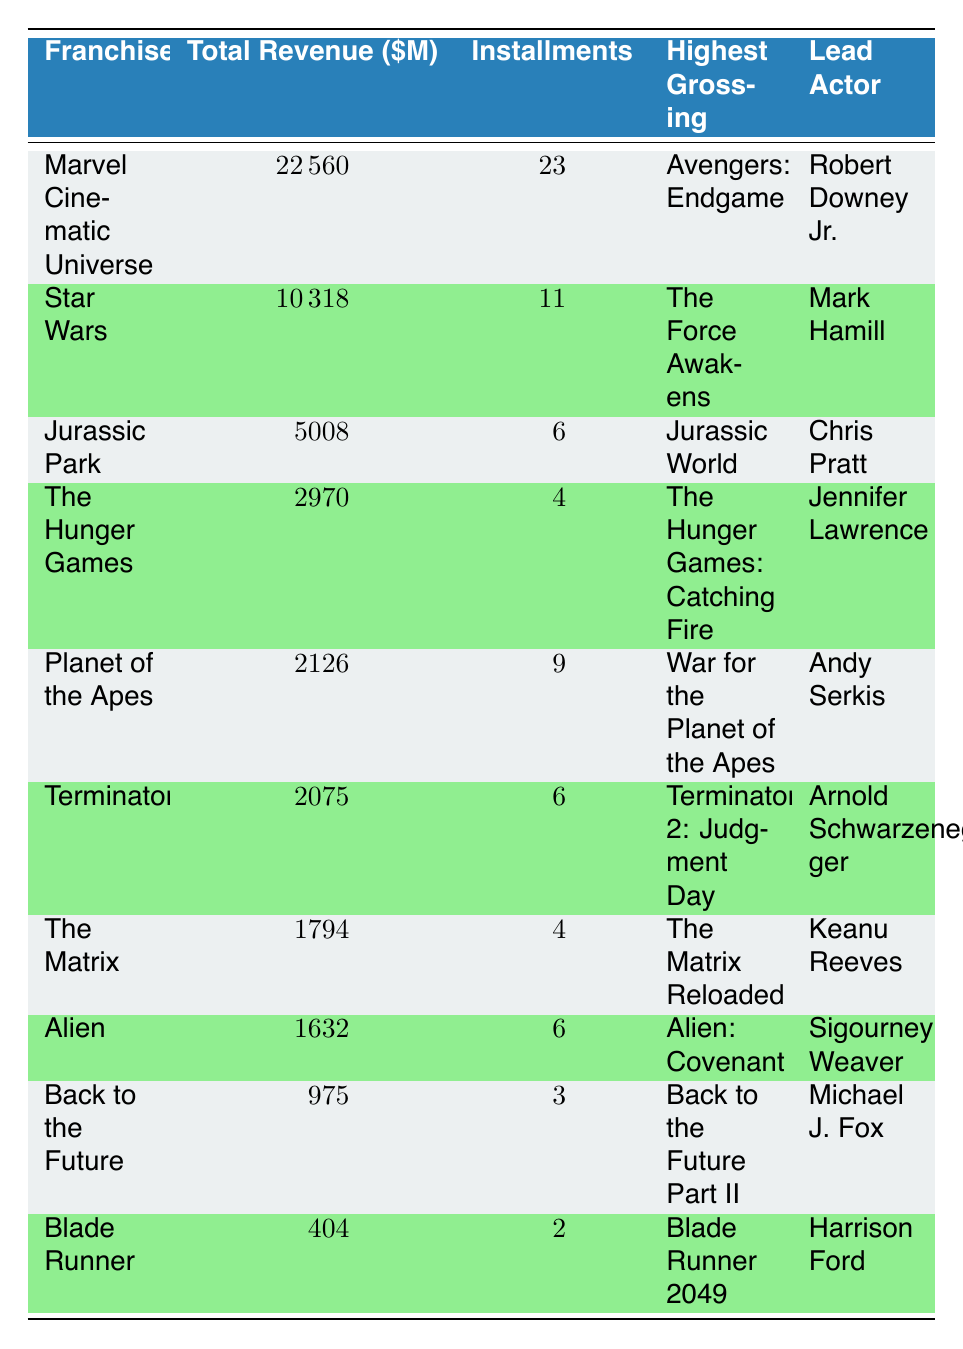What franchise has the highest total revenue? By examining the 'Total Revenue' column, we see that 'Marvel Cinematic Universe' has the highest revenue at 22560 million dollars.
Answer: Marvel Cinematic Universe How many installments does the 'Alien' franchise have? In the 'Installments' column, 'Alien' is listed with 6 installments.
Answer: 6 What is the total revenue of all the franchises combined? We sum the total revenue from each franchise: 22560 + 10318 + 5008 + 2970 + 2126 + 2075 + 1794 + 1632 + 975 + 404 = 40088. Therefore, the total revenue is 40088 million dollars.
Answer: 40088 Is 'The Hunger Games' franchise the one with the fewest installments? Looking at the 'Installments' column, we see that 'Back to the Future' has 3 installments, which is fewer than 'The Hunger Games', which has 4. Therefore, the statement is false.
Answer: No What is the average total revenue of franchises with more than 5 installments? The relevant franchises are 'Marvel Cinematic Universe' (22560), 'Star Wars' (10318), 'Jurassic Park' (5008), 'Planet of the Apes' (2126), 'Terminator' (2075), and 'Alien' (1632). Summing these gives 10318 + 22560 + 5008 + 2126 + 2075 + 1632 = 40076. There are 6 franchises, so the average is 40076/6 = approximately 6679.33.
Answer: 6679.33 What is the total revenue difference between 'Star Wars' and 'The Matrix'? From the 'Total Revenue' column, 'Star Wars' has a revenue of 10318 million, and 'The Matrix' has 1794 million. The difference is 10318 - 1794 = 8534 million dollars.
Answer: 8534 Which franchise has the highest-grossing movie, and what is the title? In the 'Highest Grossing' column, 'Avengers: Endgame' from the 'Marvel Cinematic Universe' stands out as the highest grossing.
Answer: Avengers: Endgame Which director has the most number of installments represented in this table? By looking through the table, we see that 'Star Wars' (11 installments) is directed by George Lucas and 'Marvel Cinematic Universe' (23 installments) is directed by Kevin Feige. Kevin Feige has the most installments.
Answer: Kevin Feige Are there any franchises with fewer than 4 installments? Checking the 'Installments' column, both 'Blade Runner' and 'Back to the Future' have fewer than 4 installments (2 and 3 respectively), so yes, there are franchises with fewer than 4 installments.
Answer: Yes 